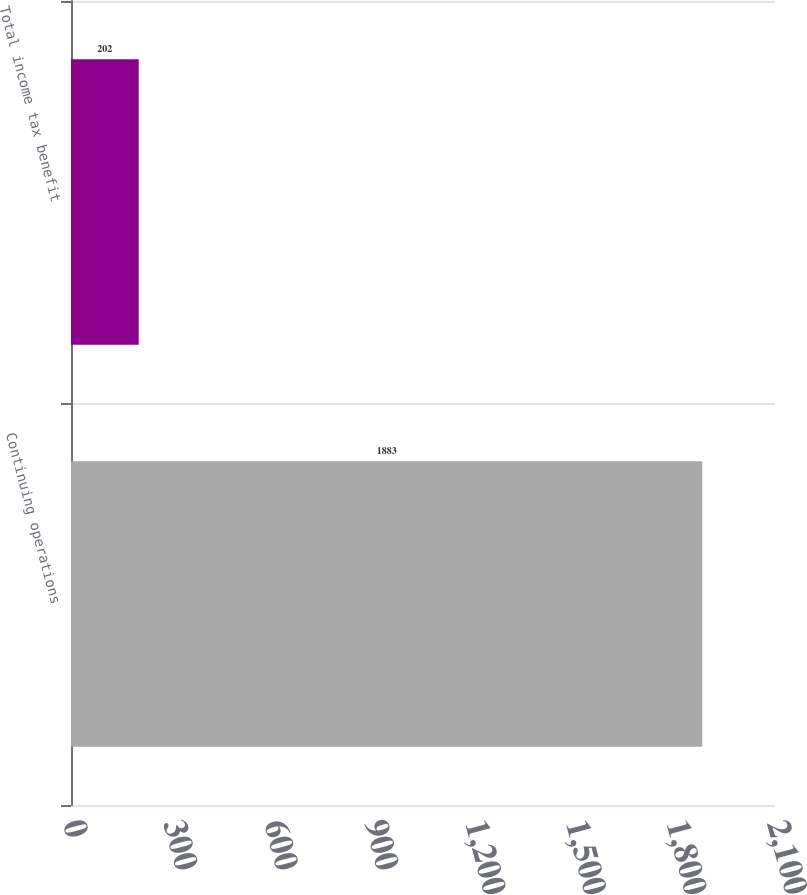<chart> <loc_0><loc_0><loc_500><loc_500><bar_chart><fcel>Continuing operations<fcel>Total income tax benefit<nl><fcel>1883<fcel>202<nl></chart> 